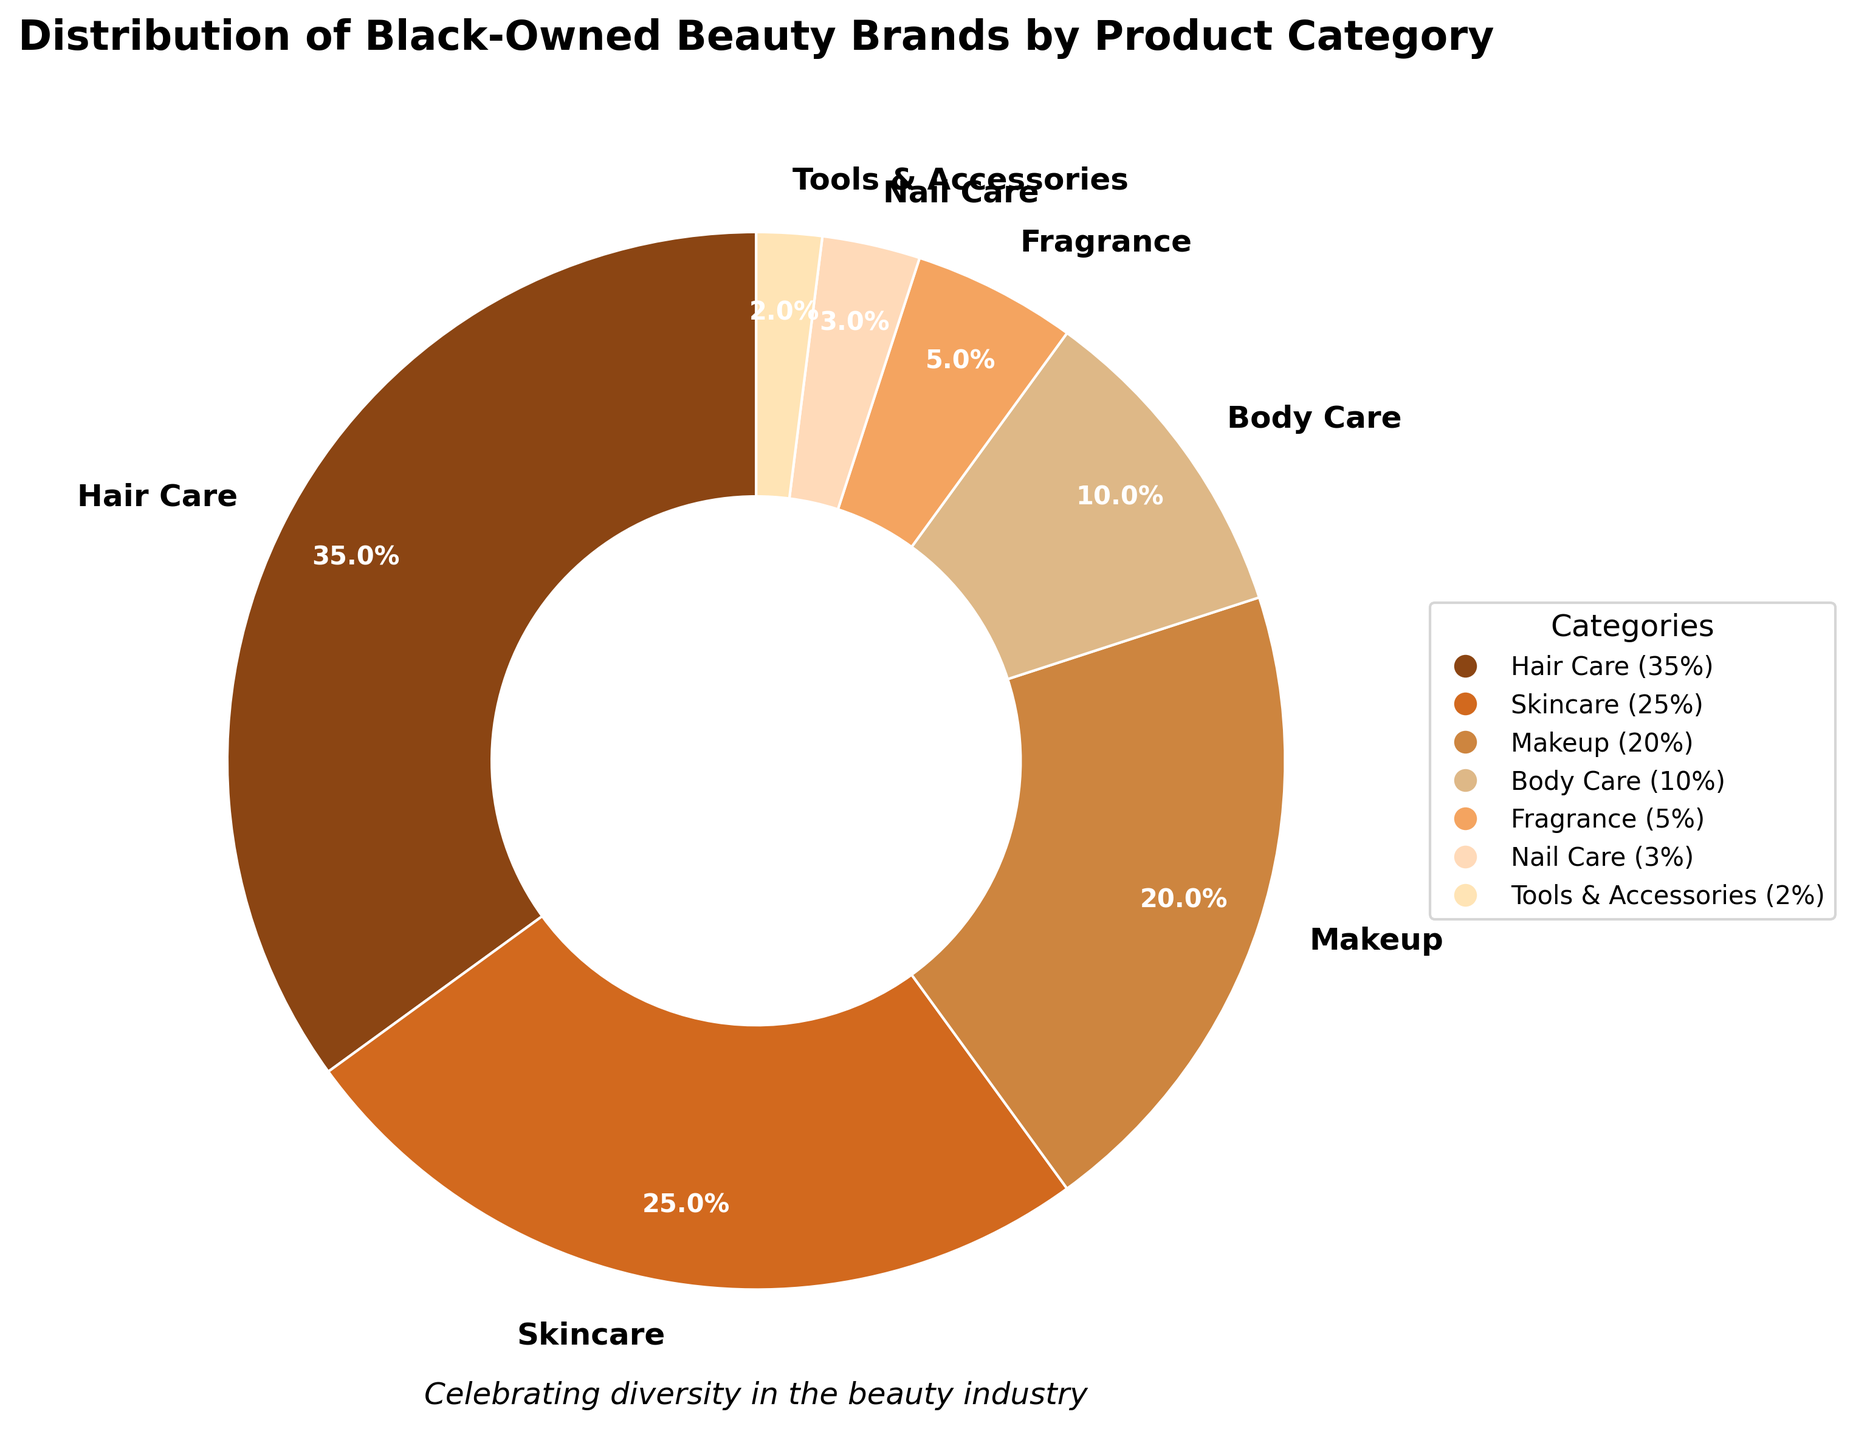What category has the largest percentage of black-owned beauty brands? The largest wedge in the pie chart represents Hair Care. It occupies the largest area, indicating it has the highest percentage.
Answer: Hair Care What is the combined percentage for Skincare and Makeup? Skincare has 25% and Makeup has 20%. Adding them together, the combined percentage is 25% + 20% = 45%.
Answer: 45% Is Body Care more prevalent than Fragrance in black-owned beauty brands? Compare the percentages for Body Care and Fragrance. Body Care has 10%, while Fragrance has 5%. Therefore, Body Care is more prevalent.
Answer: Yes Which category has the smallest representation in black-owned beauty brands and what is its percentage? The smallest wedge in the pie chart represents Tools & Accessories, which has the smallest percentage.
Answer: Tools & Accessories, 2% How much more prevalent is Hair Care than Nail Care among black-owned beauty brands? Hair Care is 35% and Nail Care is 3%. The difference is 35% - 3% = 32%.
Answer: 32% What is the total percentage represented by Hair Care, Skincare, and Makeup combined? Add the percentages for Hair Care, Skincare, and Makeup: 35% + 25% + 20% = 80%.
Answer: 80% Identify the categories that together make up less than 10% of black-owned beauty brands. From the chart, Nail Care is 3% and Tools & Accessories is 2%. Adding these together gives 3% + 2% = 5%, which is less than 10%.
Answer: Nail Care, Tools & Accessories Compare the prevalence of Body Care and Fragrance to Skincare alone. Which is greater? Body Care (10%) + Fragrance (5%) = 15%. Skincare alone is 25%. 15% < 25%, so Skincare alone is more prevalent.
Answer: Skincare alone If you combine the percentages of all categories except Hair Care, do they exceed the percentage of Hair Care? Sum the percentages of Skincare (25%), Makeup (20%), Body Care (10%), Fragrance (5%), Nail Care (3%), Tools & Accessories (2%): 25% + 20% + 10% + 5% + 3% + 2% = 65%. Since 65% > 35% (Hair Care), they do exceed it.
Answer: Yes 